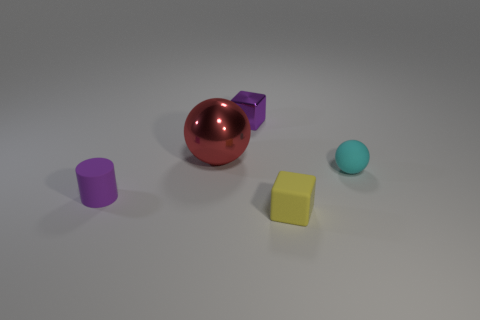How many tiny yellow objects are the same shape as the small purple metallic object?
Your answer should be compact. 1. Is the color of the tiny cylinder the same as the small metallic cube?
Ensure brevity in your answer.  Yes. What number of rubber things are big red cubes or small cyan balls?
Give a very brief answer. 1. The tiny thing that is the same color as the tiny cylinder is what shape?
Offer a terse response. Cube. Is the color of the cube that is behind the cyan object the same as the small cylinder?
Offer a very short reply. Yes. There is a purple object that is in front of the tiny cyan sphere that is behind the tiny yellow rubber thing; what is its shape?
Your answer should be compact. Cylinder. How many things are purple things in front of the small ball or small purple objects that are left of the purple metallic block?
Give a very brief answer. 1. There is a cyan object that is the same material as the yellow thing; what is its shape?
Your response must be concise. Sphere. Are there any other things that have the same color as the small matte cube?
Offer a very short reply. No. There is another small object that is the same shape as the small shiny object; what material is it?
Your answer should be compact. Rubber. 